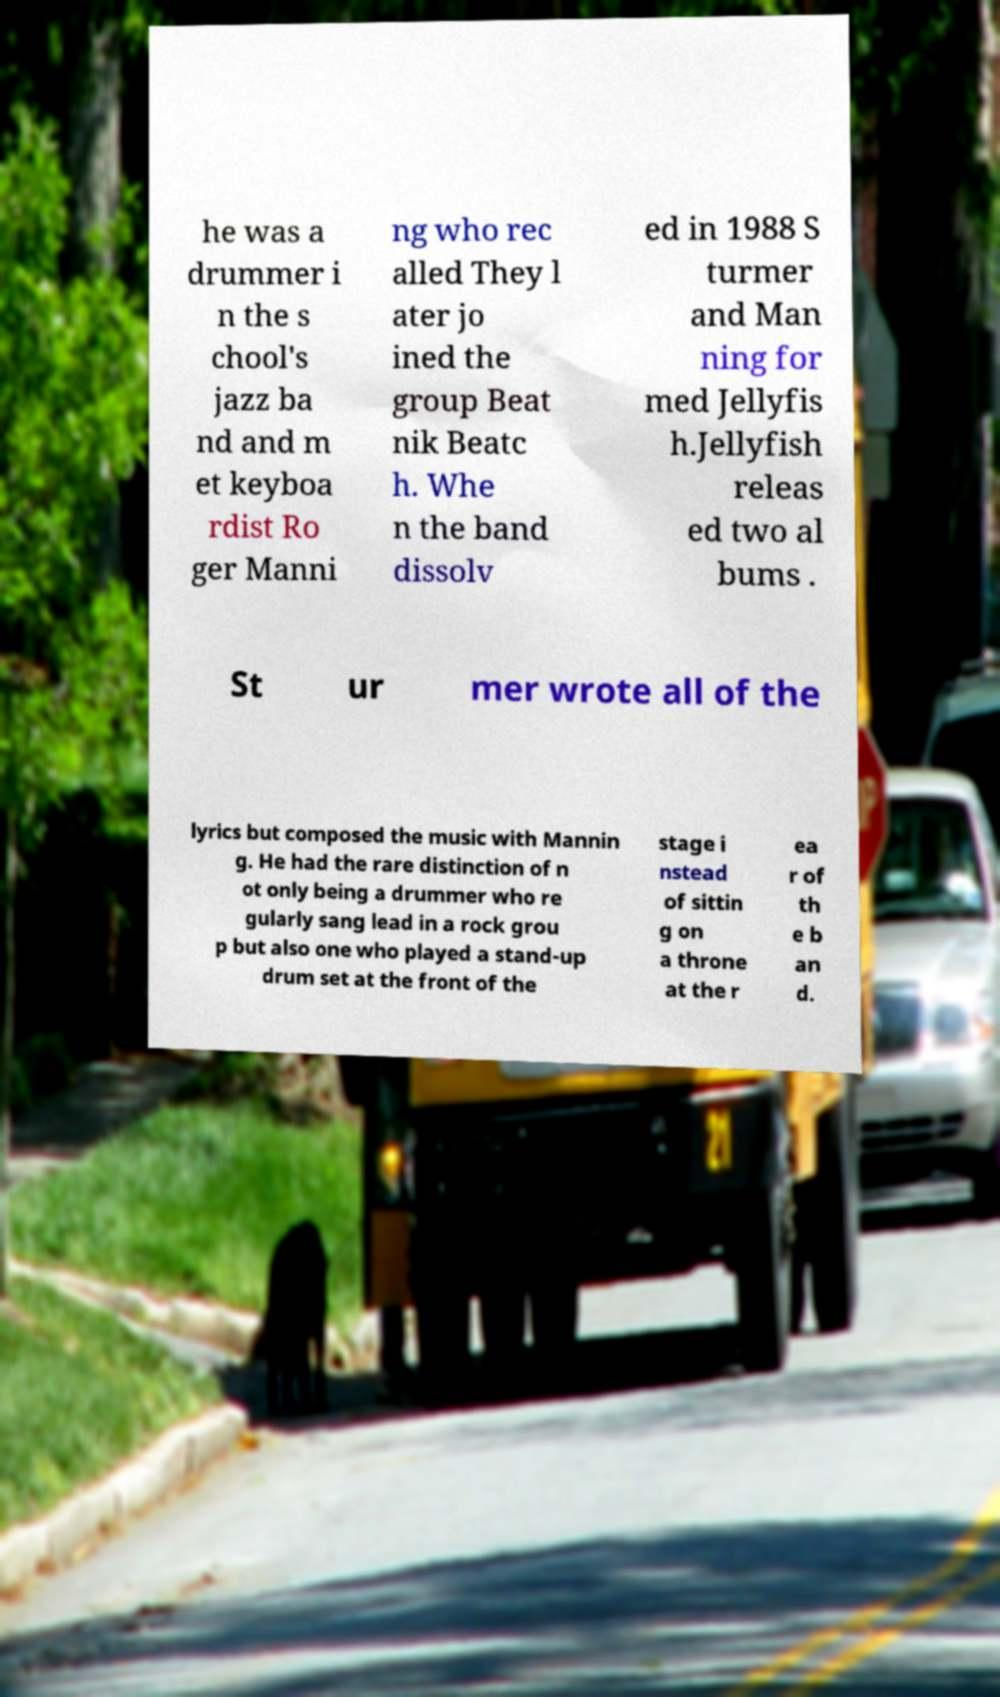Please read and relay the text visible in this image. What does it say? he was a drummer i n the s chool's jazz ba nd and m et keyboa rdist Ro ger Manni ng who rec alled They l ater jo ined the group Beat nik Beatc h. Whe n the band dissolv ed in 1988 S turmer and Man ning for med Jellyfis h.Jellyfish releas ed two al bums . St ur mer wrote all of the lyrics but composed the music with Mannin g. He had the rare distinction of n ot only being a drummer who re gularly sang lead in a rock grou p but also one who played a stand-up drum set at the front of the stage i nstead of sittin g on a throne at the r ea r of th e b an d. 